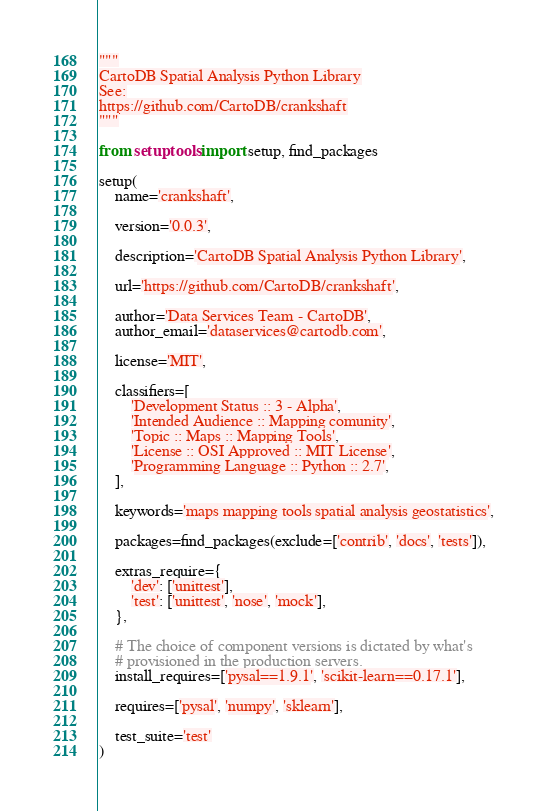Convert code to text. <code><loc_0><loc_0><loc_500><loc_500><_Python_>
"""
CartoDB Spatial Analysis Python Library
See:
https://github.com/CartoDB/crankshaft
"""

from setuptools import setup, find_packages

setup(
    name='crankshaft',

    version='0.0.3',

    description='CartoDB Spatial Analysis Python Library',

    url='https://github.com/CartoDB/crankshaft',

    author='Data Services Team - CartoDB',
    author_email='dataservices@cartodb.com',

    license='MIT',

    classifiers=[
        'Development Status :: 3 - Alpha',
        'Intended Audience :: Mapping comunity',
        'Topic :: Maps :: Mapping Tools',
        'License :: OSI Approved :: MIT License',
        'Programming Language :: Python :: 2.7',
    ],

    keywords='maps mapping tools spatial analysis geostatistics',

    packages=find_packages(exclude=['contrib', 'docs', 'tests']),

    extras_require={
        'dev': ['unittest'],
        'test': ['unittest', 'nose', 'mock'],
    },

    # The choice of component versions is dictated by what's
    # provisioned in the production servers.
    install_requires=['pysal==1.9.1', 'scikit-learn==0.17.1'],

    requires=['pysal', 'numpy', 'sklearn'],

    test_suite='test'
)
</code> 